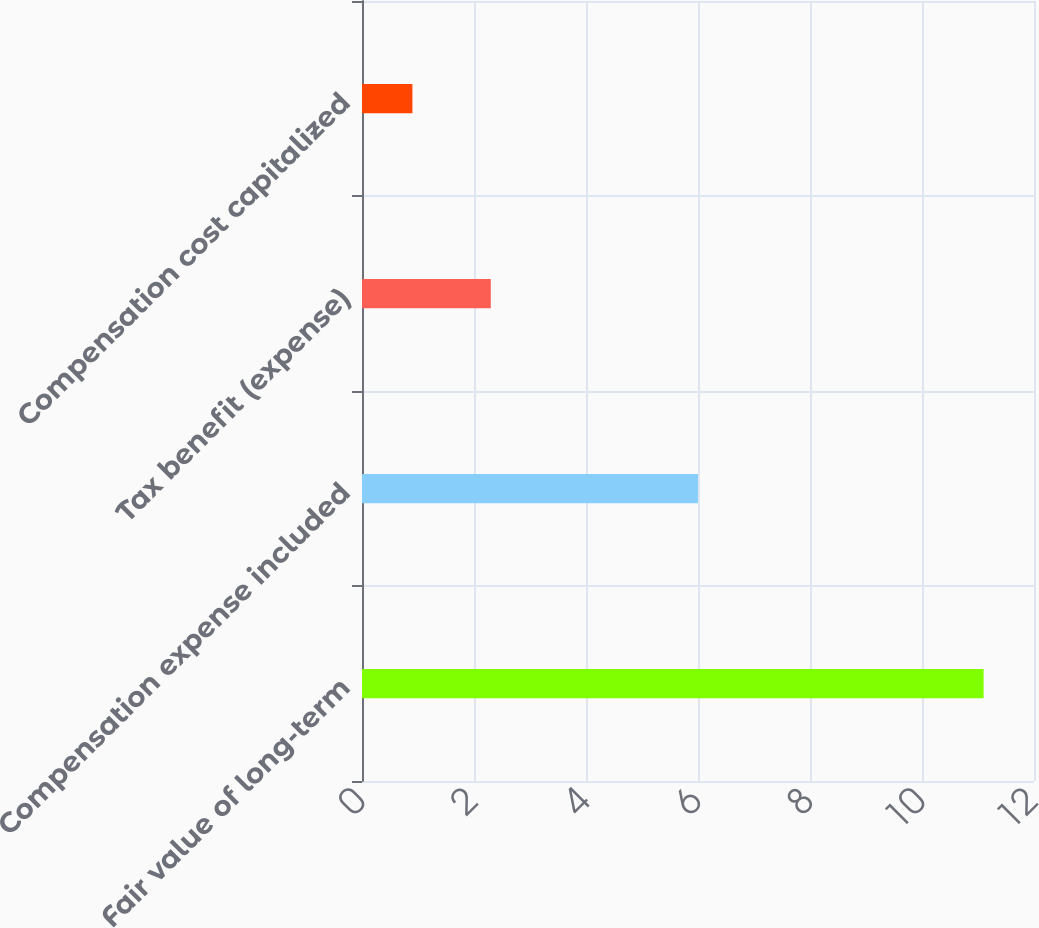Convert chart to OTSL. <chart><loc_0><loc_0><loc_500><loc_500><bar_chart><fcel>Fair value of long-term<fcel>Compensation expense included<fcel>Tax benefit (expense)<fcel>Compensation cost capitalized<nl><fcel>11.1<fcel>6<fcel>2.3<fcel>0.9<nl></chart> 